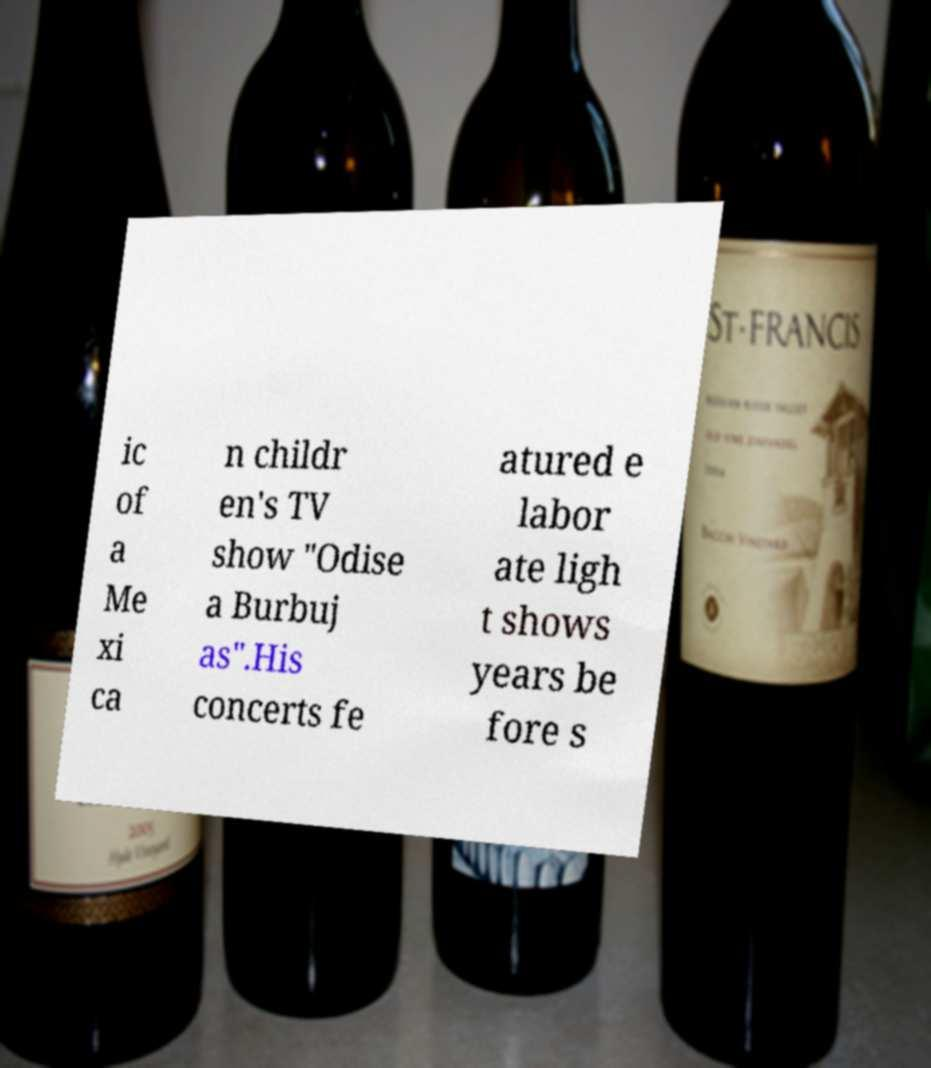Could you assist in decoding the text presented in this image and type it out clearly? ic of a Me xi ca n childr en's TV show "Odise a Burbuj as".His concerts fe atured e labor ate ligh t shows years be fore s 